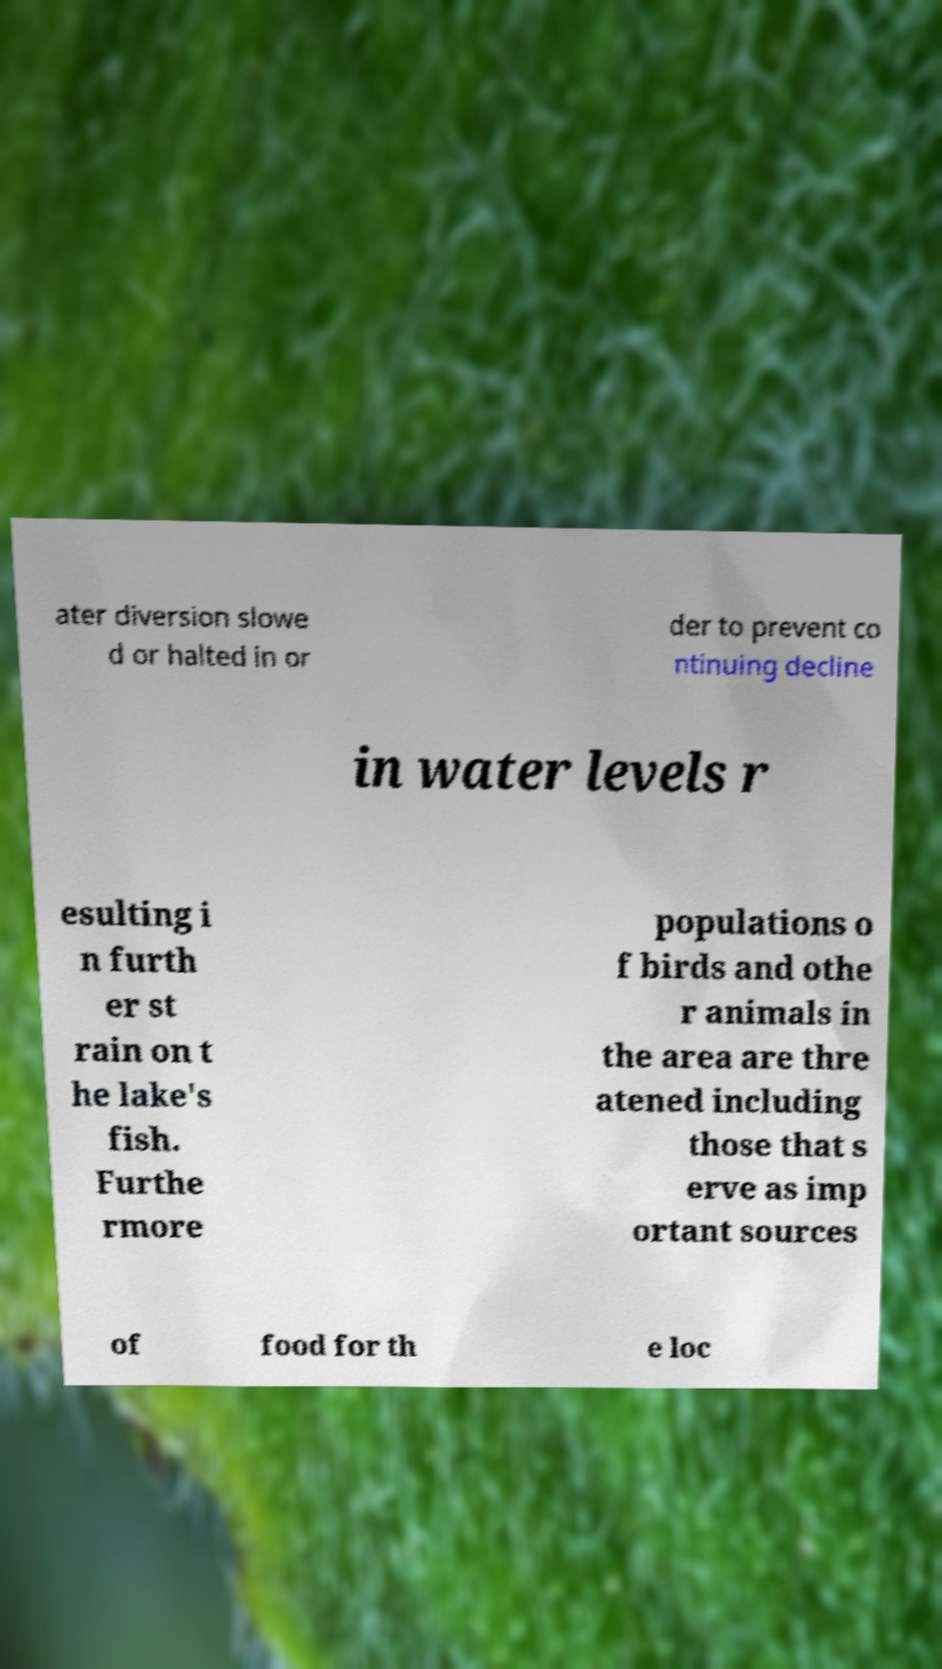For documentation purposes, I need the text within this image transcribed. Could you provide that? ater diversion slowe d or halted in or der to prevent co ntinuing decline in water levels r esulting i n furth er st rain on t he lake's fish. Furthe rmore populations o f birds and othe r animals in the area are thre atened including those that s erve as imp ortant sources of food for th e loc 